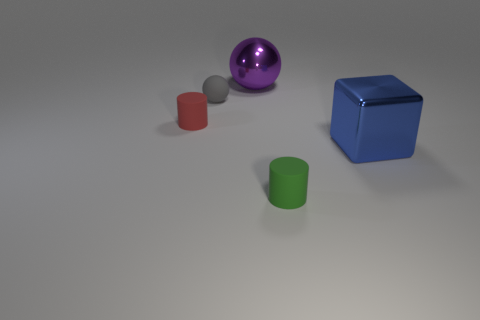Which object appears to be the largest and which one the smallest? The blue cube looks to be the largest object in the image, with its solid sides and defined edges making it stand out. On the other hand, the silver spherical object in front of the red cylinder seems to be the smallest, noticeable by its size and placement. 